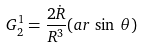Convert formula to latex. <formula><loc_0><loc_0><loc_500><loc_500>G ^ { 1 } _ { 2 } = \frac { 2 \dot { R } } { R ^ { 3 } } ( a r \, \sin \, \theta )</formula> 